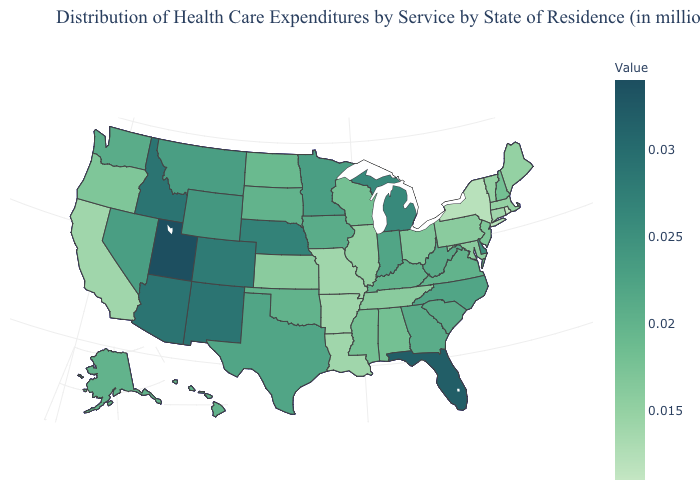Does Ohio have a lower value than Delaware?
Quick response, please. Yes. Among the states that border Vermont , which have the lowest value?
Short answer required. New York. Among the states that border Washington , does Idaho have the highest value?
Concise answer only. Yes. Which states have the lowest value in the MidWest?
Write a very short answer. Missouri. Among the states that border Nebraska , does Colorado have the lowest value?
Give a very brief answer. No. 